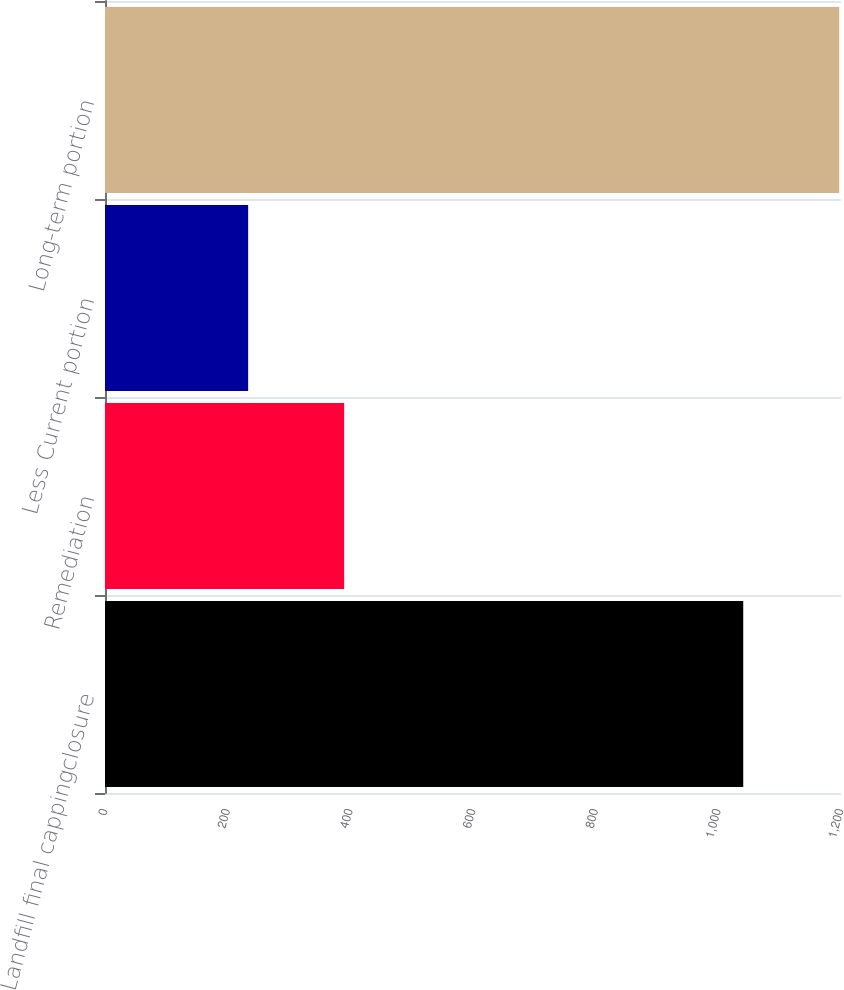<chart> <loc_0><loc_0><loc_500><loc_500><bar_chart><fcel>Landfill final cappingclosure<fcel>Remediation<fcel>Less Current portion<fcel>Long-term portion<nl><fcel>1040.6<fcel>389.9<fcel>233.4<fcel>1197.1<nl></chart> 